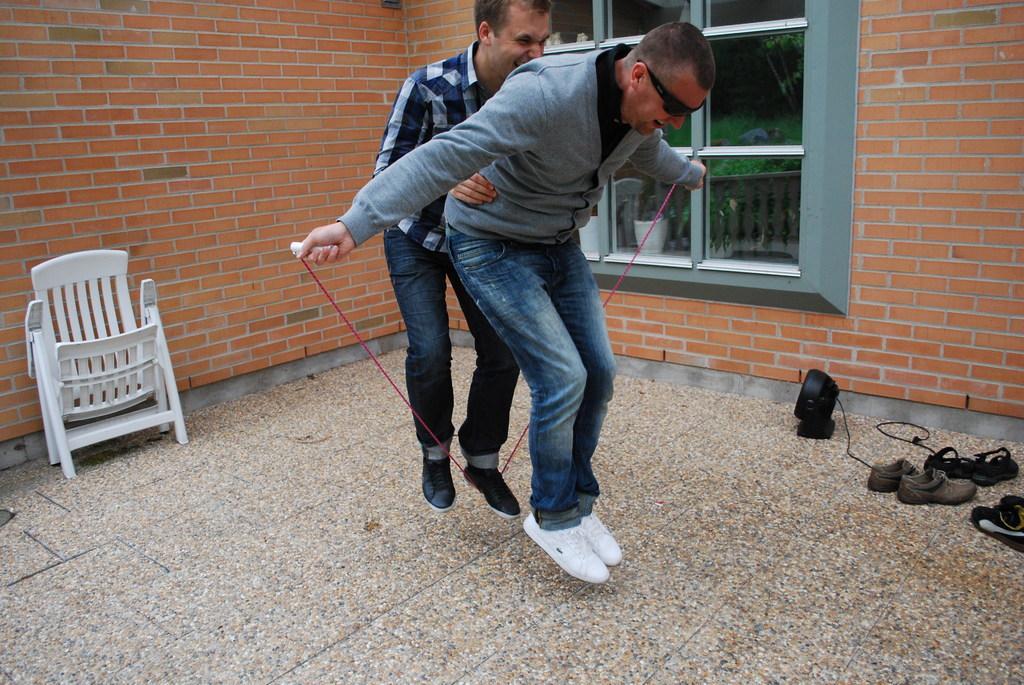In one or two sentences, can you explain what this image depicts? In the middle of the image, there are two persons smiling and jumping on the floor. On the right side, there are shoes and slippers on the floor. On the left side, there is a white color chair. In the background, there is a brick wall having glass window. 